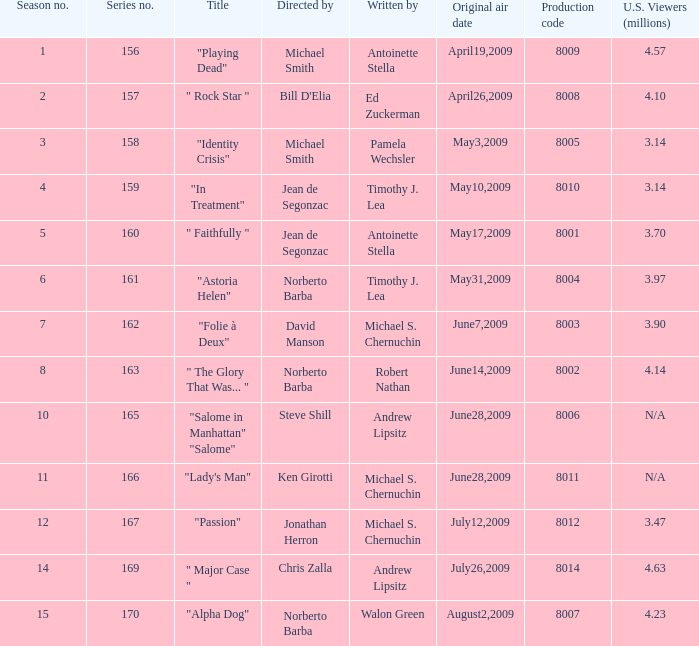Who are the writers when the production code is 8011? Michael S. Chernuchin. 